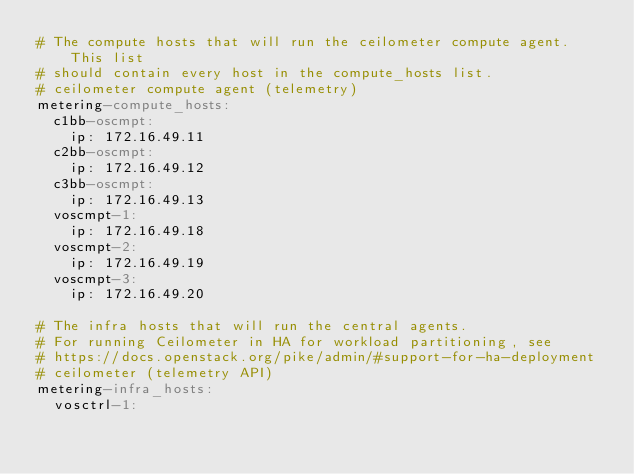Convert code to text. <code><loc_0><loc_0><loc_500><loc_500><_YAML_># The compute hosts that will run the ceilometer compute agent. This list
# should contain every host in the compute_hosts list.
# ceilometer compute agent (telemetry)
metering-compute_hosts:
  c1bb-oscmpt:
    ip: 172.16.49.11
  c2bb-oscmpt:
    ip: 172.16.49.12
  c3bb-oscmpt:
    ip: 172.16.49.13
  voscmpt-1:
    ip: 172.16.49.18
  voscmpt-2:
    ip: 172.16.49.19
  voscmpt-3:
    ip: 172.16.49.20

# The infra hosts that will run the central agents.
# For running Ceilometer in HA for workload partitioning, see
# https://docs.openstack.org/pike/admin/#support-for-ha-deployment
# ceilometer (telemetry API)
metering-infra_hosts:
  vosctrl-1:</code> 